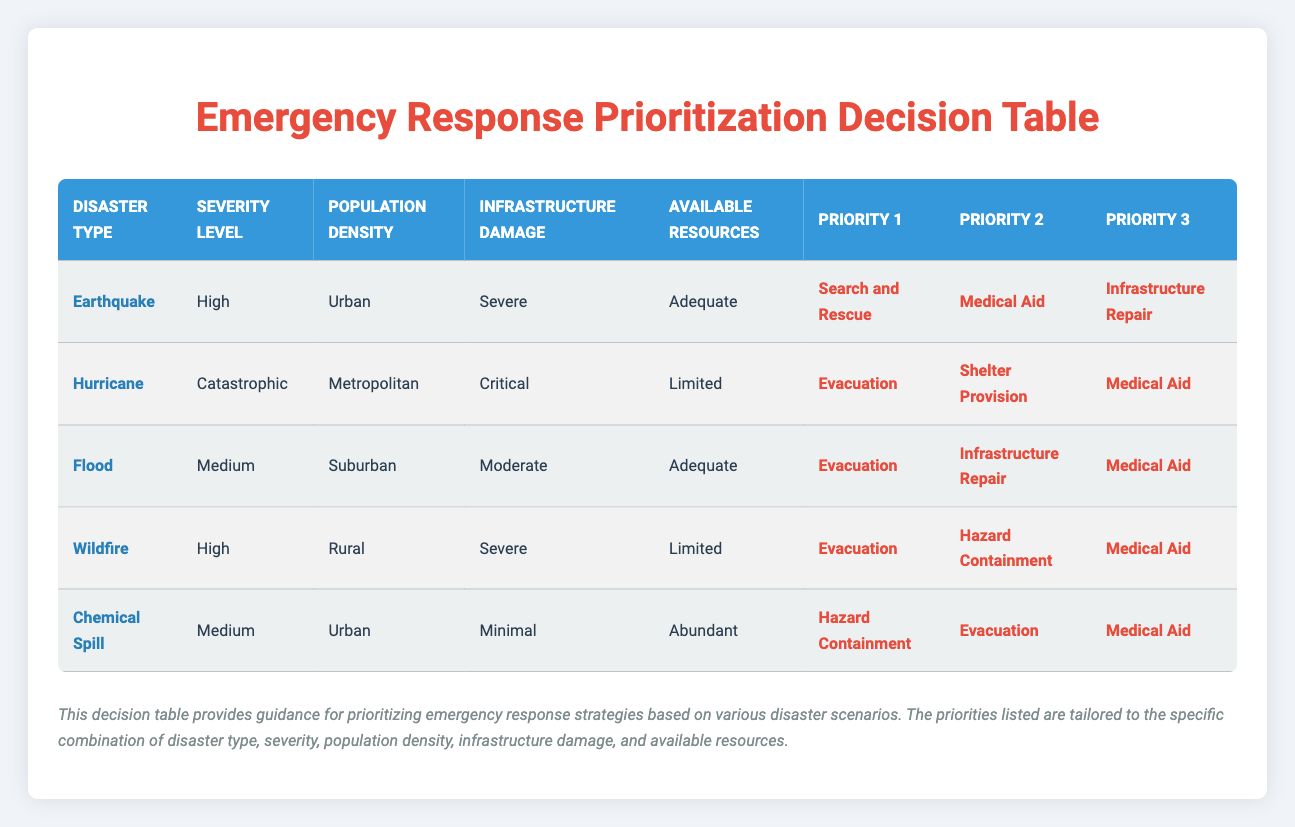What is the top priority for response in case of a catastrophic hurricane in a metropolitan area? The table indicates that for a catastrophic hurricane in a metropolitan area, the top priority is evacuation. This can be found directly in the row corresponding to "Hurricane" and "Catastrophic."
Answer: Evacuation In a scenario with a medium severity flood in a suburban area, what is the third response priority? Referring to the flood entry in the table, for a medium severity flood in a suburban area, the third response priority listed is medical aid.
Answer: Medical Aid Is "Infrastructure Repair" prioritized the same for both earthquakes and floods at high and medium severity levels? Checking the table, "Infrastructure Repair" is a priority for earthquakes at high severity (third priority) and floods at medium severity (second priority). Since the priority levels are different, they are not treated the same in terms of urgency.
Answer: No What are the response priorities for a severe wildfire in a rural area? The table shows that for a severe wildfire in a rural area, the priorities are listed as evacuation (first), hazard containment (second), and medical aid (third). This can be read directly from the row related to wildfires.
Answer: Evacuation, Hazard Containment, Medical Aid How many disaster scenarios in the table prioritize medical aid as a first response? By analyzing the table, medical aid is prioritized first only once during an earthquake scenario. The other instances of medical aid are either second or third priority.
Answer: 0 For urban areas facing a medium severity chemical spill, what are the priorities? The table states that for a medium severity chemical spill in urban areas, the first priority is hazard containment, the second priority is evacuation, and the third is medical aid. These can be directly referenced from the corresponding row.
Answer: Hazard Containment, Evacuation, Medical Aid Which disaster type has evacuation as the first priority but limited resources available? Upon checking the entries, a wildfire has evacuation as the first priority while also indicating that resources available are limited. This is evident in the row for "Wildfire."
Answer: Wildfire Are there any scenarios listed with scarce resources and infrastructure damage categorized as critical? In the table, the only disaster scenario with critical infrastructure damage is the hurricane, which has limited resources. Thus, this scenario qualifies as an instance.
Answer: Yes 